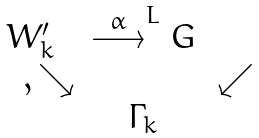<formula> <loc_0><loc_0><loc_500><loc_500>\begin{array} { c c c } W _ { k } ^ { \prime } & \stackrel { \alpha } \longrightarrow ^ { L } G \\ \quad , \searrow & & \, \swarrow \\ & \Gamma _ { k } & \\ \end{array}</formula> 